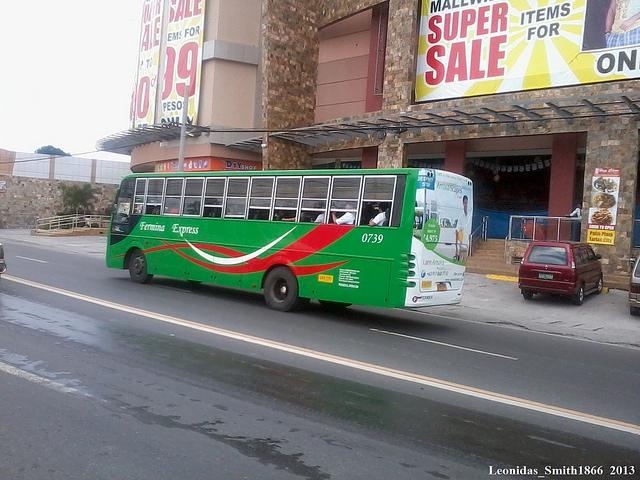Do you see a white van?
Be succinct. No. Does the ground have water on it?
Answer briefly. Yes. Is the vehicle a monorail?
Concise answer only. No. 